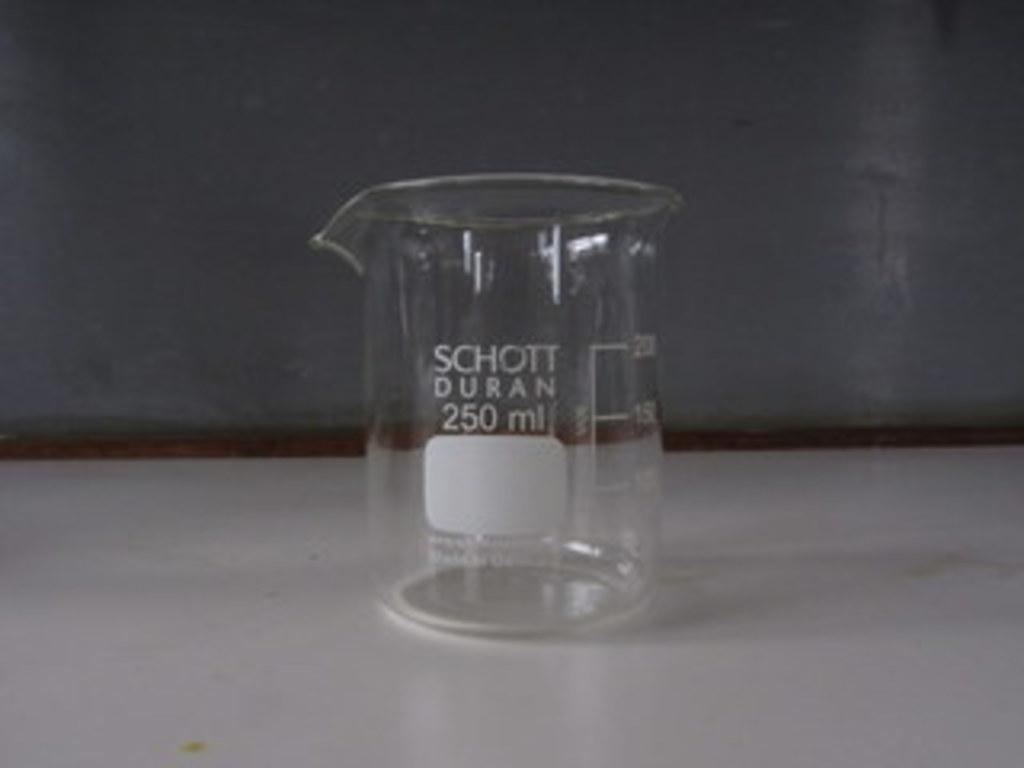<image>
Give a short and clear explanation of the subsequent image. A 250 ml scientific glass container made by SCHOTT DURAN sits on a white counter. 